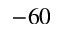Convert formula to latex. <formula><loc_0><loc_0><loc_500><loc_500>- 6 0</formula> 